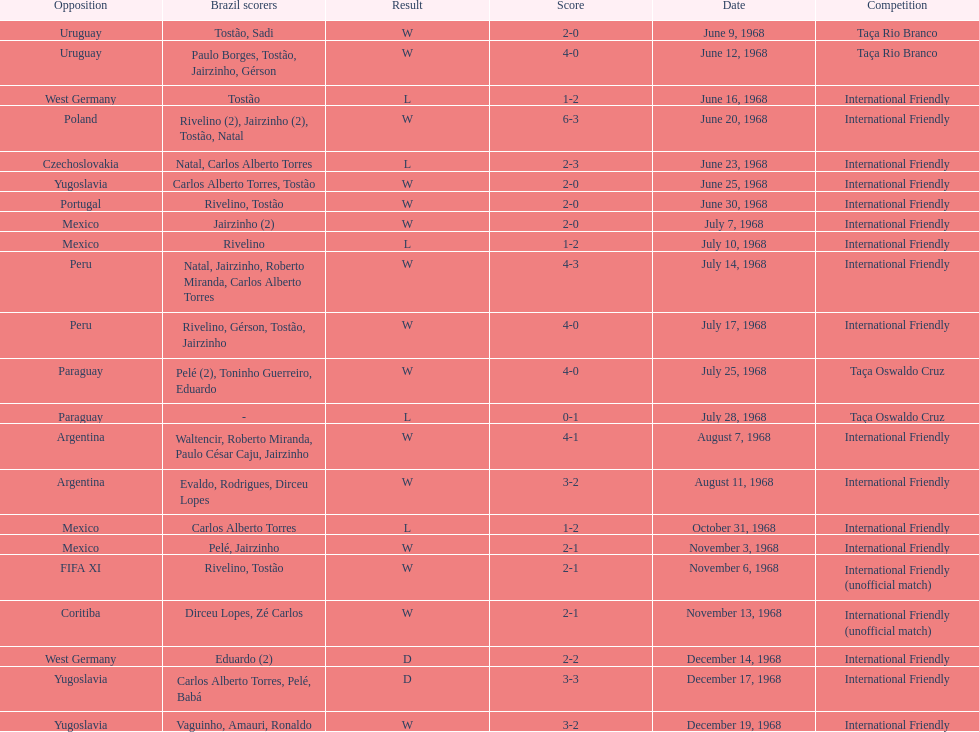Who played brazil previous to the game on june 30th? Yugoslavia. 